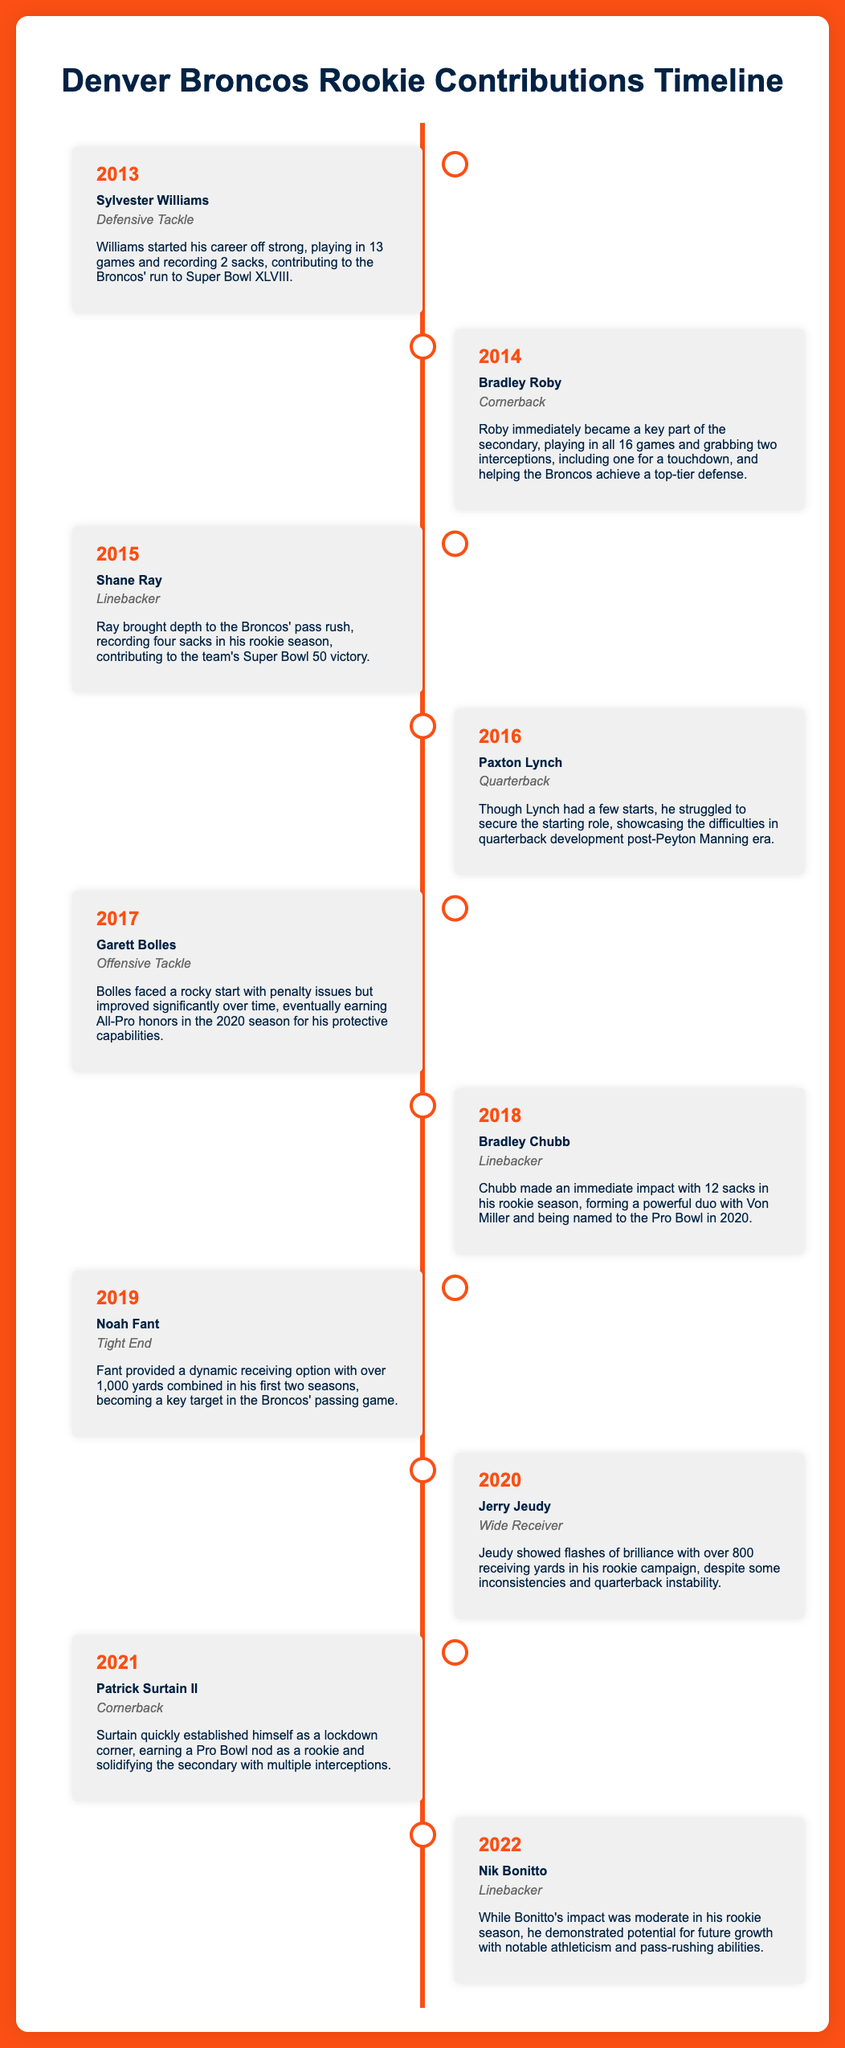What year was Sylvester Williams drafted? The timeline indicates that Sylvester Williams was a rookie in 2013.
Answer: 2013 How many sacks did Bradley Chubb record in his rookie season? The document states that Bradley Chubb made 12 sacks in his rookie season.
Answer: 12 Which position does Patrick Surtain II play? The infographic specifies that Patrick Surtain II is a cornerback.
Answer: Cornerback What notable achievement did Garett Bolles earn in 2020? The timeline highlights that Garett Bolles earned All-Pro honors in 2020.
Answer: All-Pro honors Who was the first rookie listed in the timeline? The first entry in the timeline features Sylvester Williams.
Answer: Sylvester Williams In what year did Jerry Jeudy play as a rookie? The document states that Jerry Jeudy was a rookie in 2020.
Answer: 2020 What position did Noah Fant play? The timeline identifies Noah Fant as a tight end.
Answer: Tight End How many interceptions did Bradley Roby have in 2014? The information indicates that Bradley Roby grabbed two interceptions in 2014.
Answer: Two Which player is noted for struggling after Peyton Manning? Paxton Lynch is mentioned as having struggled to secure the starting role after Manning.
Answer: Paxton Lynch 